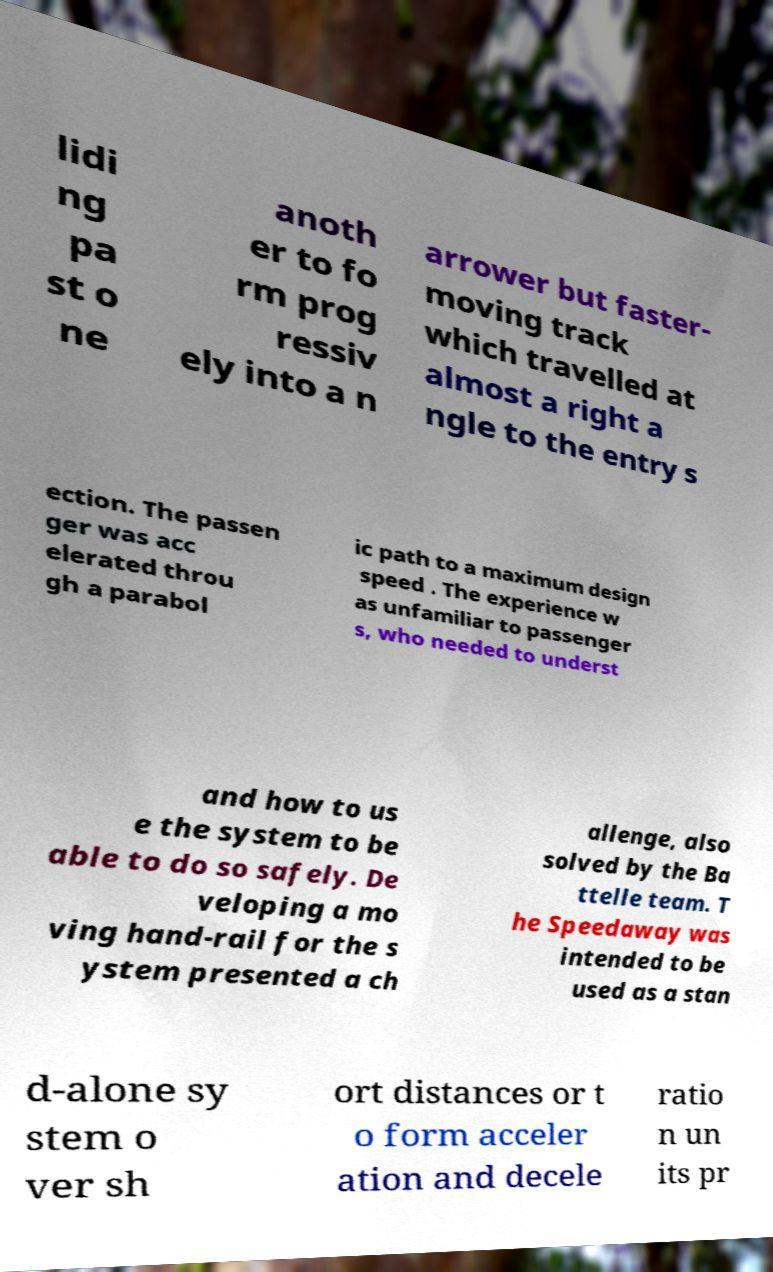Can you read and provide the text displayed in the image?This photo seems to have some interesting text. Can you extract and type it out for me? lidi ng pa st o ne anoth er to fo rm prog ressiv ely into a n arrower but faster- moving track which travelled at almost a right a ngle to the entry s ection. The passen ger was acc elerated throu gh a parabol ic path to a maximum design speed . The experience w as unfamiliar to passenger s, who needed to underst and how to us e the system to be able to do so safely. De veloping a mo ving hand-rail for the s ystem presented a ch allenge, also solved by the Ba ttelle team. T he Speedaway was intended to be used as a stan d-alone sy stem o ver sh ort distances or t o form acceler ation and decele ratio n un its pr 